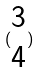<formula> <loc_0><loc_0><loc_500><loc_500>( \begin{matrix} 3 \\ 4 \end{matrix} )</formula> 